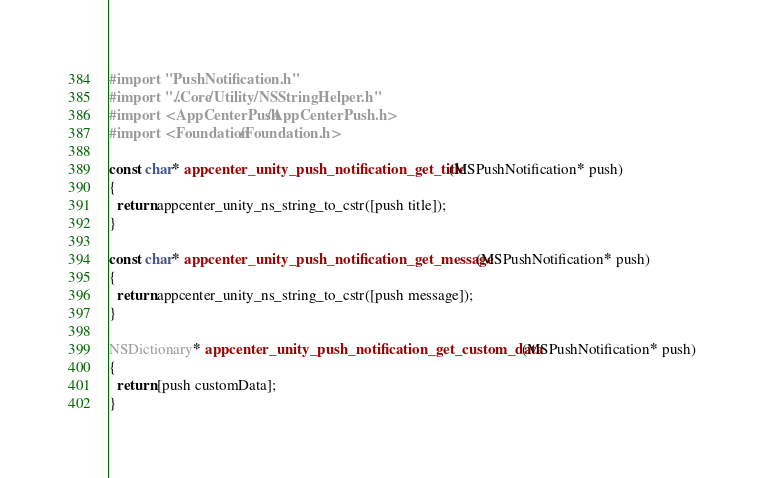<code> <loc_0><loc_0><loc_500><loc_500><_ObjectiveC_>
#import "PushNotification.h"
#import "../Core/Utility/NSStringHelper.h"
#import <AppCenterPush/AppCenterPush.h>
#import <Foundation/Foundation.h>

const char* appcenter_unity_push_notification_get_title(MSPushNotification* push)
{
  return appcenter_unity_ns_string_to_cstr([push title]);
}

const char* appcenter_unity_push_notification_get_message(MSPushNotification* push)
{
  return appcenter_unity_ns_string_to_cstr([push message]);
}

NSDictionary* appcenter_unity_push_notification_get_custom_data(MSPushNotification* push)
{
  return [push customData];
}
</code> 